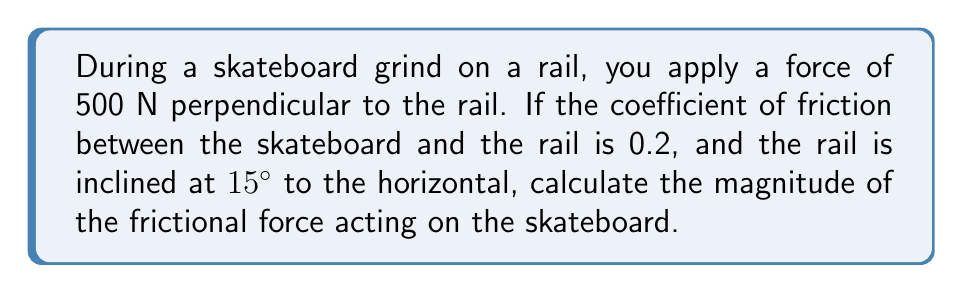Solve this math problem. Let's approach this step-by-step:

1) First, let's identify the forces acting on the skateboard:
   - Normal force (N) perpendicular to the rail
   - Frictional force (f) parallel to the rail
   - Weight of the skateboarder (mg) acting vertically downwards

2) We're given that the applied force perpendicular to the rail is 500 N. This is equal to the normal force:

   $N = 500 \text{ N}$

3) The coefficient of friction (μ) is given as 0.2.

4) To find the frictional force, we use the formula:

   $f = \mu N$

5) Substituting the values:

   $f = 0.2 \times 500 = 100 \text{ N}$

6) However, we need to consider the inclination of the rail. The 15° incline doesn't affect the magnitude of the frictional force in this case, as we calculated it based on the normal force perpendicular to the rail.

7) If we wanted to resolve this force into horizontal and vertical components:
   
   $f_x = f \cos(15°) = 100 \cos(15°) = 96.59 \text{ N}$
   $f_y = f \sin(15°) = 100 \sin(15°) = 25.88 \text{ N}$

But the question asks for the magnitude of the frictional force, which is simply 100 N.
Answer: 100 N 